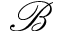Convert formula to latex. <formula><loc_0><loc_0><loc_500><loc_500>\mathcal { B }</formula> 